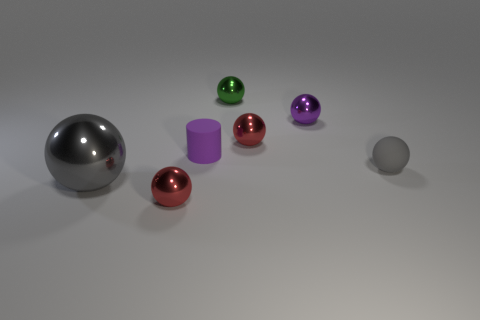Is the color of the small matte thing to the right of the purple cylinder the same as the big metallic ball?
Your response must be concise. Yes. Are there any other things that are the same color as the big shiny sphere?
Offer a very short reply. Yes. What is the shape of the small rubber object that is the same color as the large shiny ball?
Keep it short and to the point. Sphere. Do the purple thing that is behind the small purple rubber cylinder and the large gray thing have the same shape?
Your answer should be compact. Yes. How many objects are either small shiny spheres that are in front of the small green metal object or large cyan cubes?
Provide a short and direct response. 3. Are there any tiny purple metallic objects that have the same shape as the big gray thing?
Offer a terse response. Yes. What shape is the green thing that is the same size as the cylinder?
Provide a short and direct response. Sphere. What is the shape of the tiny object in front of the gray metallic thing left of the small red object that is on the right side of the tiny green shiny thing?
Ensure brevity in your answer.  Sphere. Do the tiny gray object and the small red thing that is in front of the small purple matte thing have the same shape?
Keep it short and to the point. Yes. What number of large objects are purple spheres or yellow cylinders?
Provide a short and direct response. 0. 